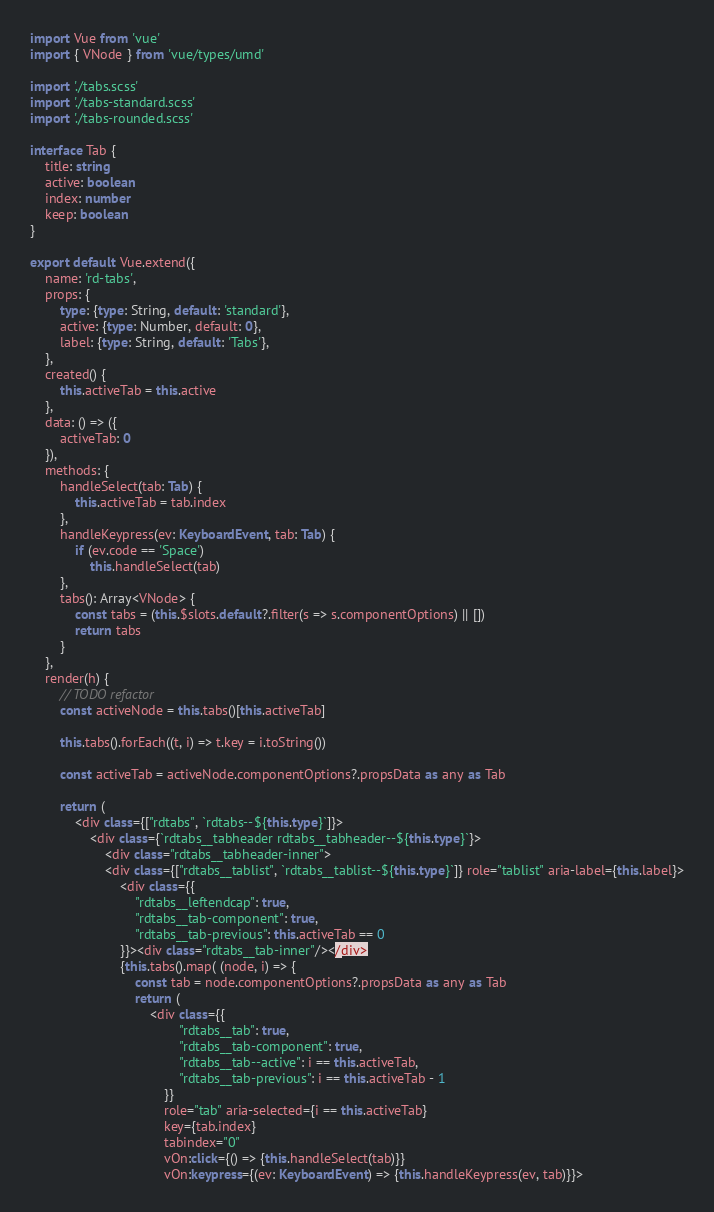<code> <loc_0><loc_0><loc_500><loc_500><_TypeScript_>import Vue from 'vue'
import { VNode } from 'vue/types/umd'

import './tabs.scss'
import './tabs-standard.scss'
import './tabs-rounded.scss'

interface Tab {
    title: string
    active: boolean
    index: number
    keep: boolean
}

export default Vue.extend({
    name: 'rd-tabs',
    props: {
        type: {type: String, default: 'standard'},
        active: {type: Number, default: 0},
        label: {type: String, default: 'Tabs'},
    },
    created() {
        this.activeTab = this.active
    },
    data: () => ({
        activeTab: 0
    }),
    methods: {
        handleSelect(tab: Tab) {
            this.activeTab = tab.index
        },
        handleKeypress(ev: KeyboardEvent, tab: Tab) {
            if (ev.code == 'Space')
                this.handleSelect(tab)
        },
        tabs(): Array<VNode> {
            const tabs = (this.$slots.default?.filter(s => s.componentOptions) || [])
            return tabs
        }
    },
    render(h) {
        // TODO refactor
        const activeNode = this.tabs()[this.activeTab]

        this.tabs().forEach((t, i) => t.key = i.toString())

        const activeTab = activeNode.componentOptions?.propsData as any as Tab

        return (
            <div class={["rdtabs", `rdtabs--${this.type}`]}>
                <div class={`rdtabs__tabheader rdtabs__tabheader--${this.type}`}>
                    <div class="rdtabs__tabheader-inner">
                    <div class={["rdtabs__tablist", `rdtabs__tablist--${this.type}`]} role="tablist" aria-label={this.label}>
                        <div class={{
                            "rdtabs__leftendcap": true,
                            "rdtabs__tab-component": true,
                            "rdtabs__tab-previous": this.activeTab == 0
                        }}><div class="rdtabs__tab-inner"/></div>
                        {this.tabs().map( (node, i) => {
                            const tab = node.componentOptions?.propsData as any as Tab
                            return (
                                <div class={{
                                        "rdtabs__tab": true,
                                        "rdtabs__tab-component": true,
                                        "rdtabs__tab--active": i == this.activeTab,
                                        "rdtabs__tab-previous": i == this.activeTab - 1
                                    }}
                                    role="tab" aria-selected={i == this.activeTab}
                                    key={tab.index}
                                    tabindex="0"
                                    vOn:click={() => {this.handleSelect(tab)}}
                                    vOn:keypress={(ev: KeyboardEvent) => {this.handleKeypress(ev, tab)}}></code> 